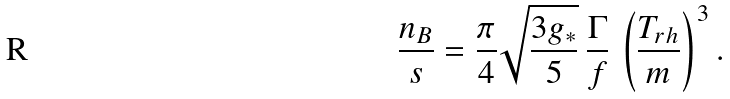<formula> <loc_0><loc_0><loc_500><loc_500>\frac { n _ { B } } { s } = \frac { \pi } { 4 } \sqrt { \frac { 3 g _ { * } } { 5 } } \, \frac { \Gamma } { f } \, \left ( \frac { T _ { r h } } { m } \right ) ^ { 3 } .</formula> 